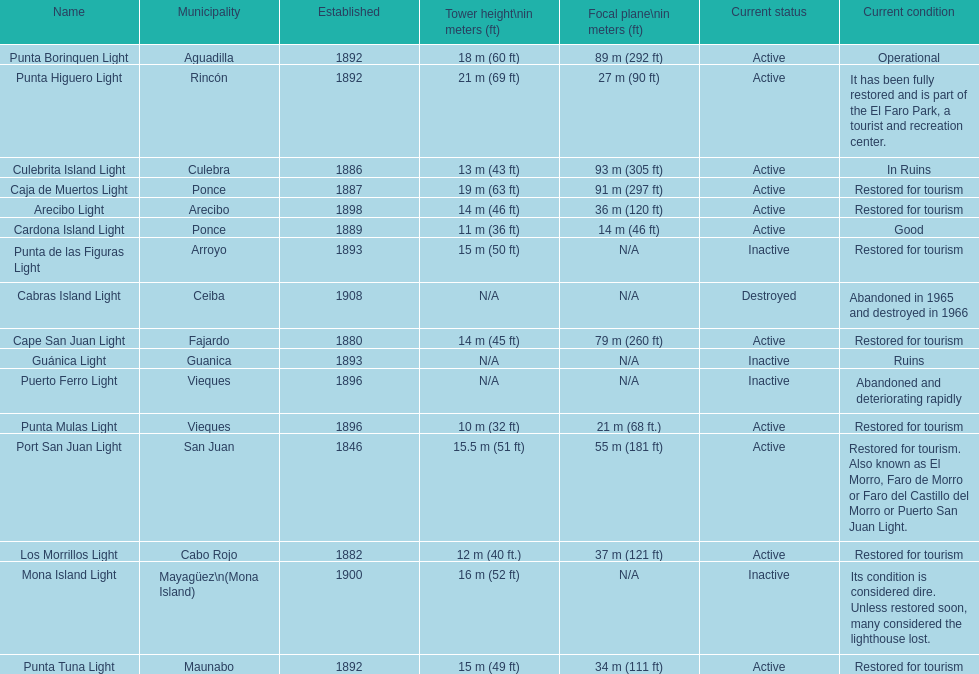Which municipality was the first to be established? San Juan. Can you parse all the data within this table? {'header': ['Name', 'Municipality', 'Established', 'Tower height\\nin meters (ft)', 'Focal plane\\nin meters (ft)', 'Current status', 'Current condition'], 'rows': [['Punta Borinquen Light', 'Aguadilla', '1892', '18\xa0m (60\xa0ft)', '89\xa0m (292\xa0ft)', 'Active', 'Operational'], ['Punta Higuero Light', 'Rincón', '1892', '21\xa0m (69\xa0ft)', '27\xa0m (90\xa0ft)', 'Active', 'It has been fully restored and is part of the El Faro Park, a tourist and recreation center.'], ['Culebrita Island Light', 'Culebra', '1886', '13\xa0m (43\xa0ft)', '93\xa0m (305\xa0ft)', 'Active', 'In Ruins'], ['Caja de Muertos Light', 'Ponce', '1887', '19\xa0m (63\xa0ft)', '91\xa0m (297\xa0ft)', 'Active', 'Restored for tourism'], ['Arecibo Light', 'Arecibo', '1898', '14\xa0m (46\xa0ft)', '36\xa0m (120\xa0ft)', 'Active', 'Restored for tourism'], ['Cardona Island Light', 'Ponce', '1889', '11\xa0m (36\xa0ft)', '14\xa0m (46\xa0ft)', 'Active', 'Good'], ['Punta de las Figuras Light', 'Arroyo', '1893', '15\xa0m (50\xa0ft)', 'N/A', 'Inactive', 'Restored for tourism'], ['Cabras Island Light', 'Ceiba', '1908', 'N/A', 'N/A', 'Destroyed', 'Abandoned in 1965 and destroyed in 1966'], ['Cape San Juan Light', 'Fajardo', '1880', '14\xa0m (45\xa0ft)', '79\xa0m (260\xa0ft)', 'Active', 'Restored for tourism'], ['Guánica Light', 'Guanica', '1893', 'N/A', 'N/A', 'Inactive', 'Ruins'], ['Puerto Ferro Light', 'Vieques', '1896', 'N/A', 'N/A', 'Inactive', 'Abandoned and deteriorating rapidly'], ['Punta Mulas Light', 'Vieques', '1896', '10\xa0m (32\xa0ft)', '21\xa0m (68\xa0ft.)', 'Active', 'Restored for tourism'], ['Port San Juan Light', 'San Juan', '1846', '15.5\xa0m (51\xa0ft)', '55\xa0m (181\xa0ft)', 'Active', 'Restored for tourism. Also known as El Morro, Faro de Morro or Faro del Castillo del Morro or Puerto San Juan Light.'], ['Los Morrillos Light', 'Cabo Rojo', '1882', '12\xa0m (40\xa0ft.)', '37\xa0m (121\xa0ft)', 'Active', 'Restored for tourism'], ['Mona Island Light', 'Mayagüez\\n(Mona Island)', '1900', '16\xa0m (52\xa0ft)', 'N/A', 'Inactive', 'Its condition is considered dire. Unless restored soon, many considered the lighthouse lost.'], ['Punta Tuna Light', 'Maunabo', '1892', '15\xa0m (49\xa0ft)', '34\xa0m (111\xa0ft)', 'Active', 'Restored for tourism']]} 